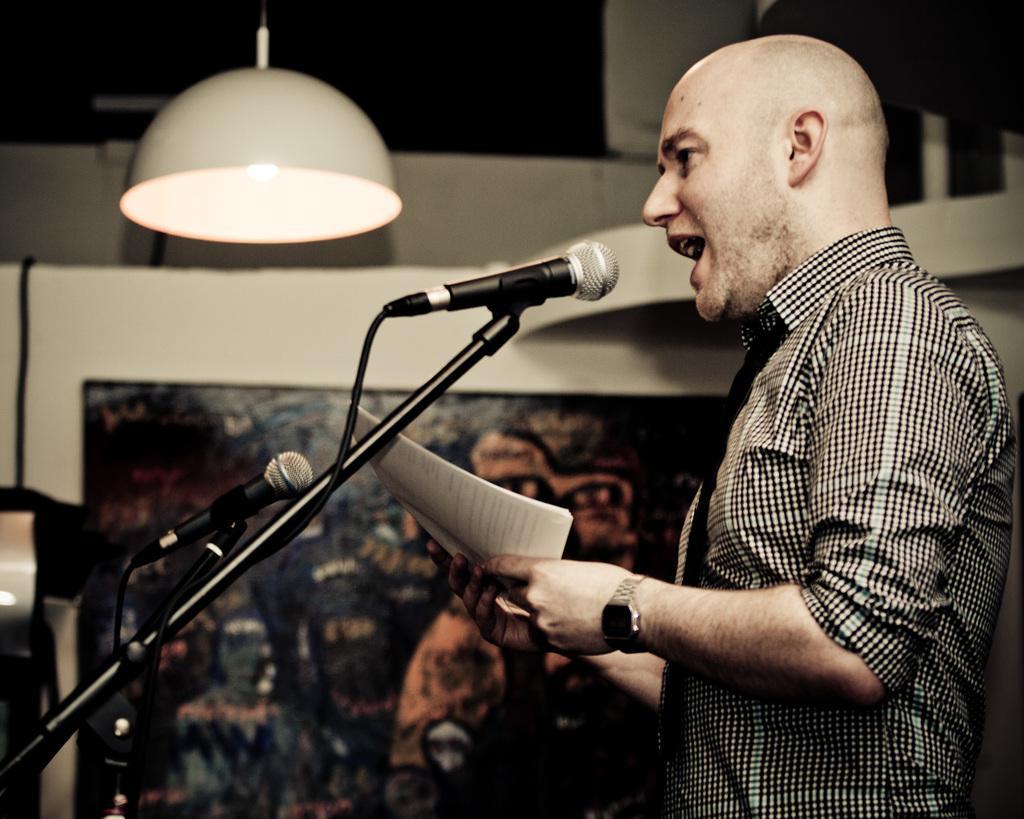Describe this image in one or two sentences. In this image I can see a person standing wearing black and white shirt. The person is singing in front of the microphone holding few papers, at the back I can see the other microphone, a frame attached to the wall and the wall is in white color, at top I can see a light. 